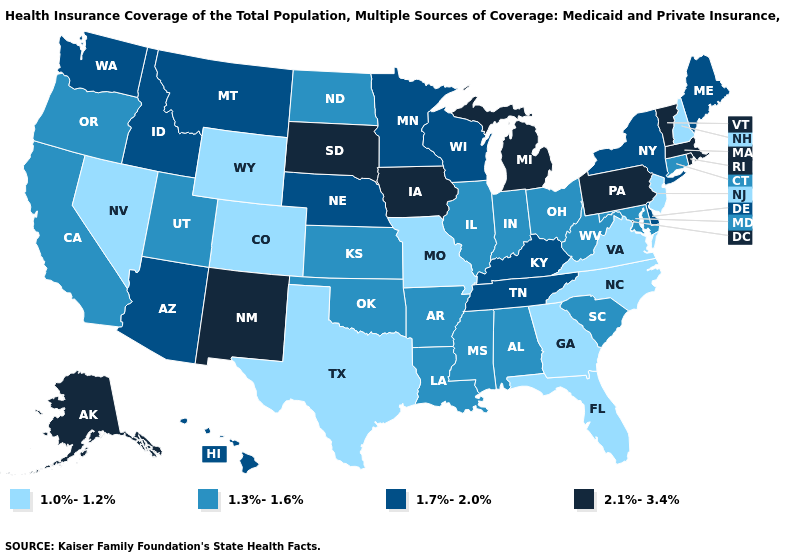Among the states that border Arizona , which have the highest value?
Give a very brief answer. New Mexico. Does Hawaii have the same value as Maryland?
Be succinct. No. Name the states that have a value in the range 2.1%-3.4%?
Short answer required. Alaska, Iowa, Massachusetts, Michigan, New Mexico, Pennsylvania, Rhode Island, South Dakota, Vermont. What is the value of Alaska?
Short answer required. 2.1%-3.4%. Does the map have missing data?
Be succinct. No. Does Michigan have a higher value than Iowa?
Give a very brief answer. No. What is the value of Vermont?
Keep it brief. 2.1%-3.4%. Name the states that have a value in the range 1.7%-2.0%?
Give a very brief answer. Arizona, Delaware, Hawaii, Idaho, Kentucky, Maine, Minnesota, Montana, Nebraska, New York, Tennessee, Washington, Wisconsin. What is the value of Georgia?
Quick response, please. 1.0%-1.2%. Name the states that have a value in the range 1.0%-1.2%?
Be succinct. Colorado, Florida, Georgia, Missouri, Nevada, New Hampshire, New Jersey, North Carolina, Texas, Virginia, Wyoming. How many symbols are there in the legend?
Answer briefly. 4. What is the value of Kentucky?
Write a very short answer. 1.7%-2.0%. Does the map have missing data?
Keep it brief. No. Name the states that have a value in the range 1.0%-1.2%?
Write a very short answer. Colorado, Florida, Georgia, Missouri, Nevada, New Hampshire, New Jersey, North Carolina, Texas, Virginia, Wyoming. What is the value of North Dakota?
Write a very short answer. 1.3%-1.6%. 